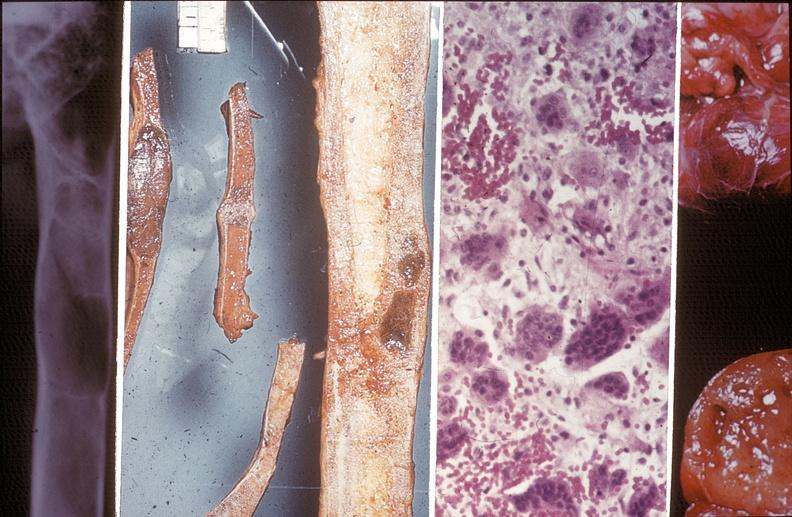does this image show bone, hyperparathyroidism,?
Answer the question using a single word or phrase. Yes 